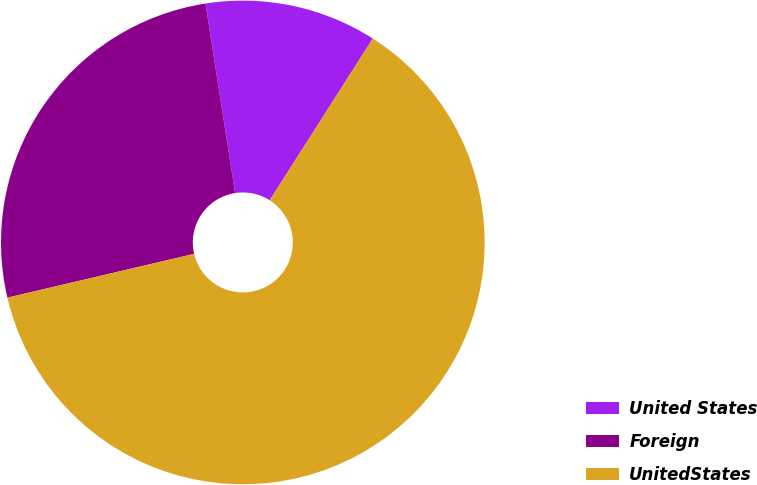Convert chart. <chart><loc_0><loc_0><loc_500><loc_500><pie_chart><fcel>United States<fcel>Foreign<fcel>UnitedStates<nl><fcel>11.5%<fcel>26.2%<fcel>62.3%<nl></chart> 